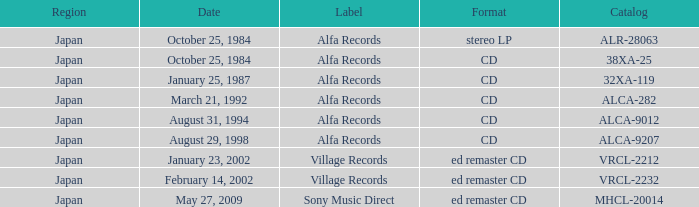What was the region of the release from May 27, 2009? Japan. 